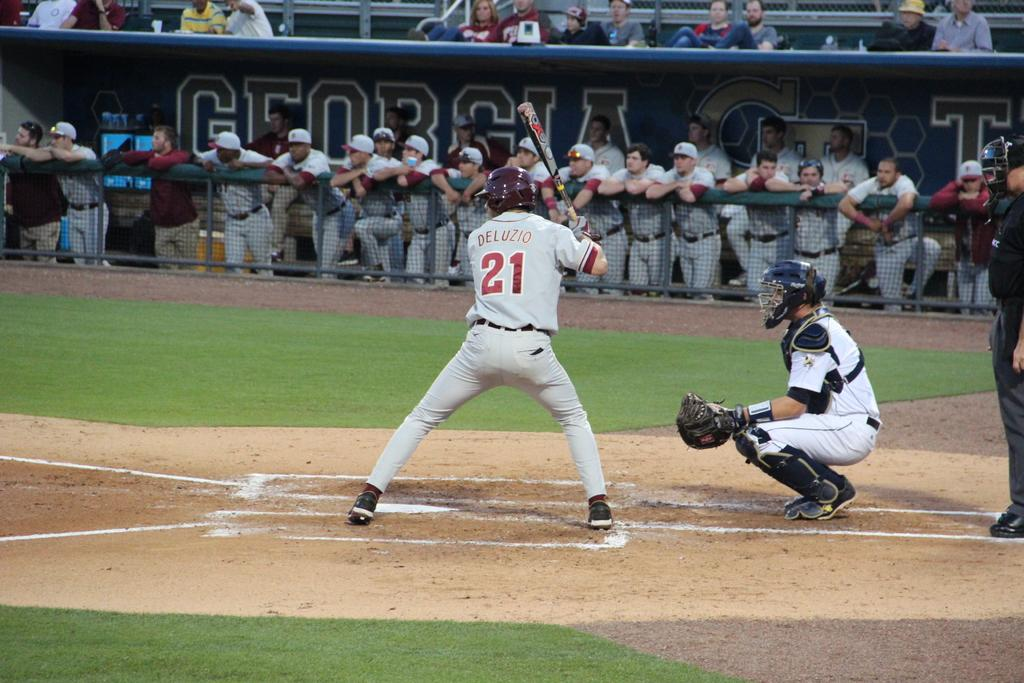<image>
Provide a brief description of the given image. Two Baseball players playing baseball one has 21 on his shirt. 